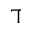Convert formula to latex. <formula><loc_0><loc_0><loc_500><loc_500>\daleth</formula> 